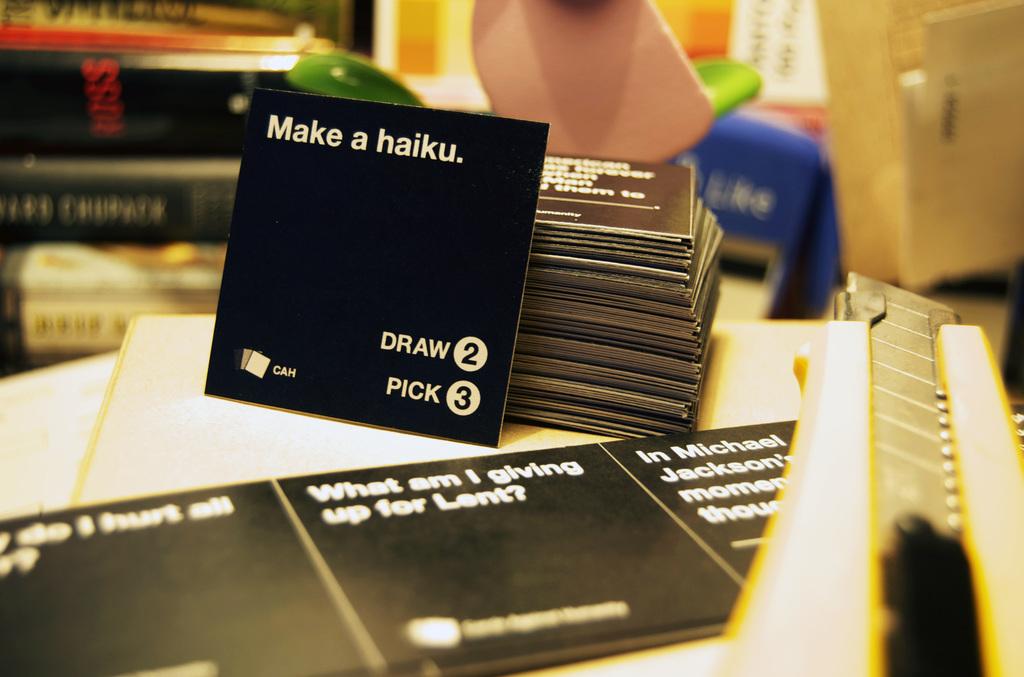What does the upright card ask you to make?
Give a very brief answer. A haiku. What does #3 say?
Offer a terse response. Pick. 